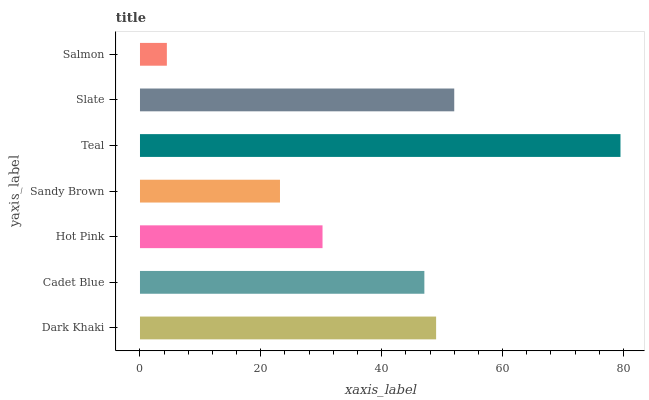Is Salmon the minimum?
Answer yes or no. Yes. Is Teal the maximum?
Answer yes or no. Yes. Is Cadet Blue the minimum?
Answer yes or no. No. Is Cadet Blue the maximum?
Answer yes or no. No. Is Dark Khaki greater than Cadet Blue?
Answer yes or no. Yes. Is Cadet Blue less than Dark Khaki?
Answer yes or no. Yes. Is Cadet Blue greater than Dark Khaki?
Answer yes or no. No. Is Dark Khaki less than Cadet Blue?
Answer yes or no. No. Is Cadet Blue the high median?
Answer yes or no. Yes. Is Cadet Blue the low median?
Answer yes or no. Yes. Is Hot Pink the high median?
Answer yes or no. No. Is Teal the low median?
Answer yes or no. No. 